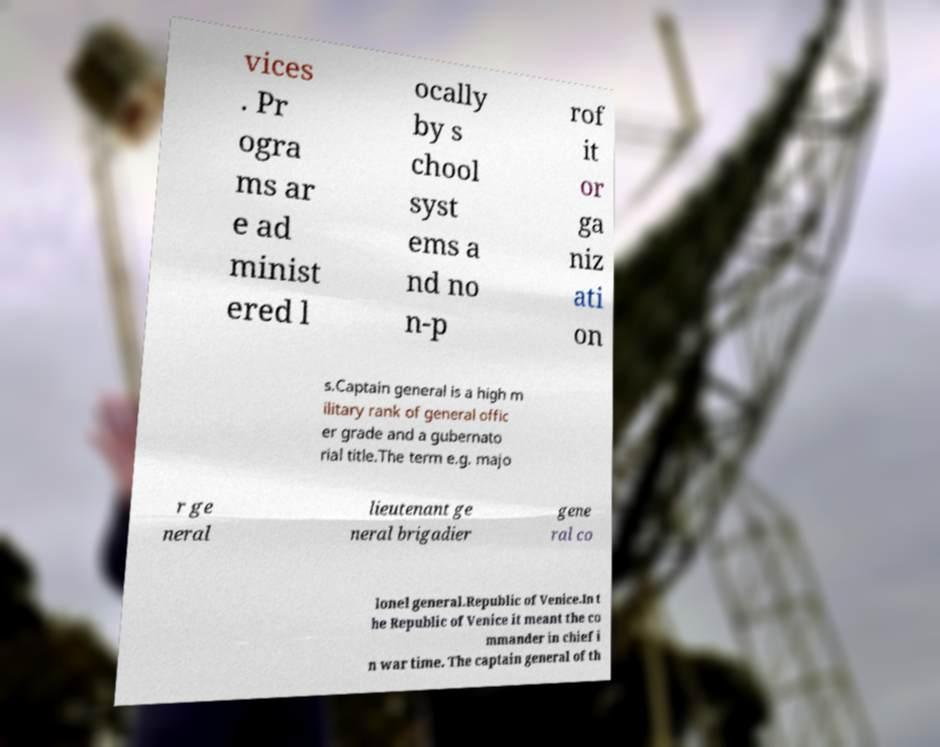Please read and relay the text visible in this image. What does it say? vices . Pr ogra ms ar e ad minist ered l ocally by s chool syst ems a nd no n-p rof it or ga niz ati on s.Captain general is a high m ilitary rank of general offic er grade and a gubernato rial title.The term e.g. majo r ge neral lieutenant ge neral brigadier gene ral co lonel general.Republic of Venice.In t he Republic of Venice it meant the co mmander in chief i n war time. The captain general of th 